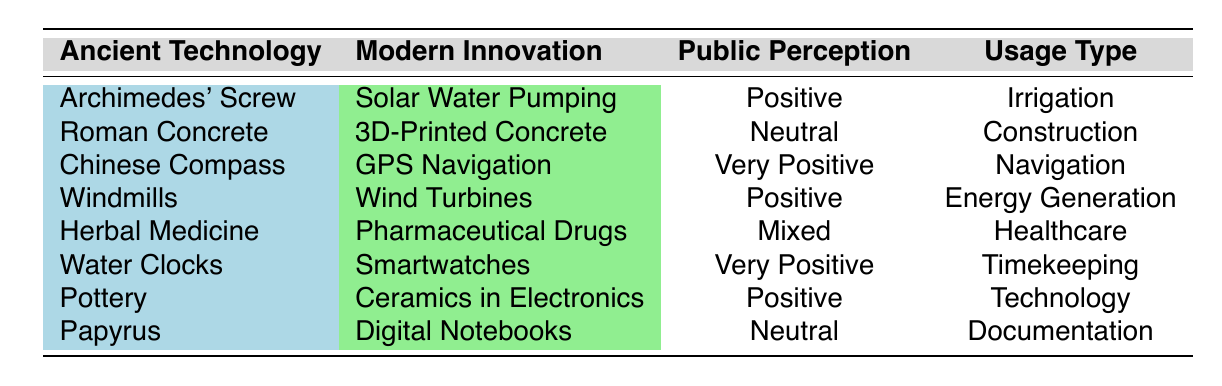What is the public perception of Archimedes' Screw? The table lists the public perception of Archimedes' Screw as "Positive." This information can be found directly under the "Public Perception" column associated with the row for Archimedes' Screw.
Answer: Positive Which modern innovation has the most favorable public perception? The table shows that "GPS Navigation" and "Smartwatches" both have the public perception listed as "Very Positive." These are the only two innovations with such a perception, making them favorable.
Answer: GPS Navigation, Smartwatches How many technologies have a neutral public perception? By examining the "Public Perception" column, we find two entries marked as "Neutral": Roman Concrete and Papyrus. Counting these entries gives us the total.
Answer: 2 What is the difference in the number of technologies with positive perception versus very positive perception? From the data, there are four technologies with a "Positive" perception (Archimedes' Screw, Windmills, Pottery, Herbal Medicine) and two with a "Very Positive" perception (Chinese Compass and Smartwatches). To find the difference, we subtract the number of "Very Positive" from "Positive": 4 - 2 = 2.
Answer: 2 Is there any technology categorized under healthcare with a mixed perception? The table indicates that "Herbal Medicine" is categorized under healthcare and has a "Mixed" perception. Therefore, this statement is true when cross-referenced with the data.
Answer: Yes Which ancient technology corresponds to the modern innovation of Digital Notebooks? Looking at the row for Digital Notebooks, we can see that the ancient technology associated with it is "Papyrus." This direct association is clear in the table format.
Answer: Papyrus What is the total number of ancient technologies linked to energy generation? The table shows that there are two energy-related technologies: Windmills (linked to Wind Turbines) and Archimedes' Screw (linked to Solar Water Pumping). Thus, the total count comes from these entries.
Answer: 2 What percentage of technologies received a positive or very positive public perception? There are five technologies (Archimedes' Screw, Chinese Compass, Windmills, Water Clocks, Pottery) with either a "Positive" or "Very Positive" perception, out of a total of eight technologies. To find the percentage, (5/8) * 100 = 62.5%. Thus, the result should be expressed as 62.5%.
Answer: 62.5% 